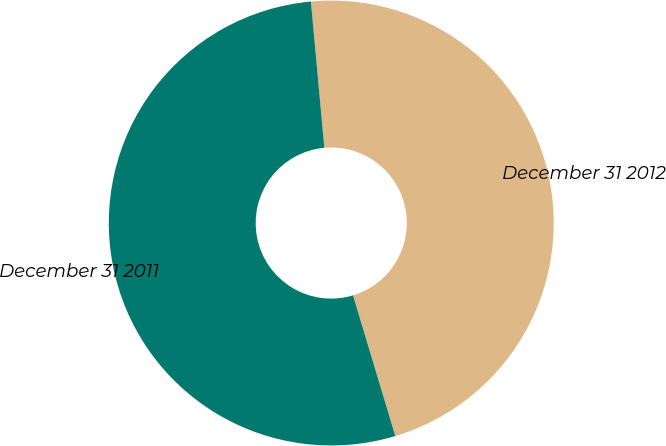<chart> <loc_0><loc_0><loc_500><loc_500><pie_chart><fcel>December 31 2012<fcel>December 31 2011<nl><fcel>46.81%<fcel>53.19%<nl></chart> 